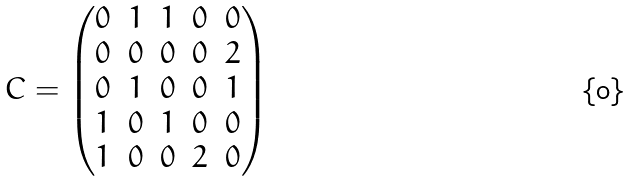Convert formula to latex. <formula><loc_0><loc_0><loc_500><loc_500>C = \begin{pmatrix} 0 & 1 & 1 & 0 & 0 \\ 0 & 0 & 0 & 0 & 2 \\ 0 & 1 & 0 & 0 & 1 \\ 1 & 0 & 1 & 0 & 0 \\ 1 & 0 & 0 & 2 & 0 \end{pmatrix}</formula> 